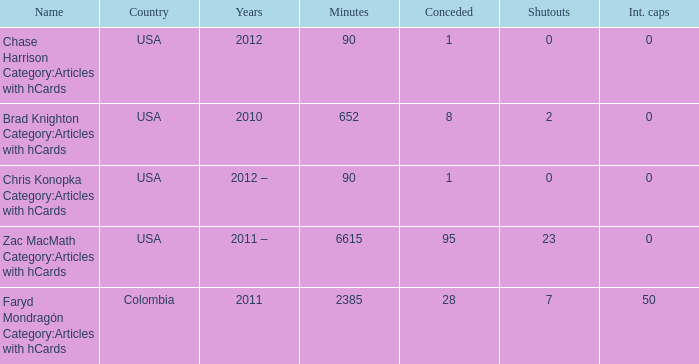When chase harrison category:articles containing hcards is the name, which year is it? 2012.0. 